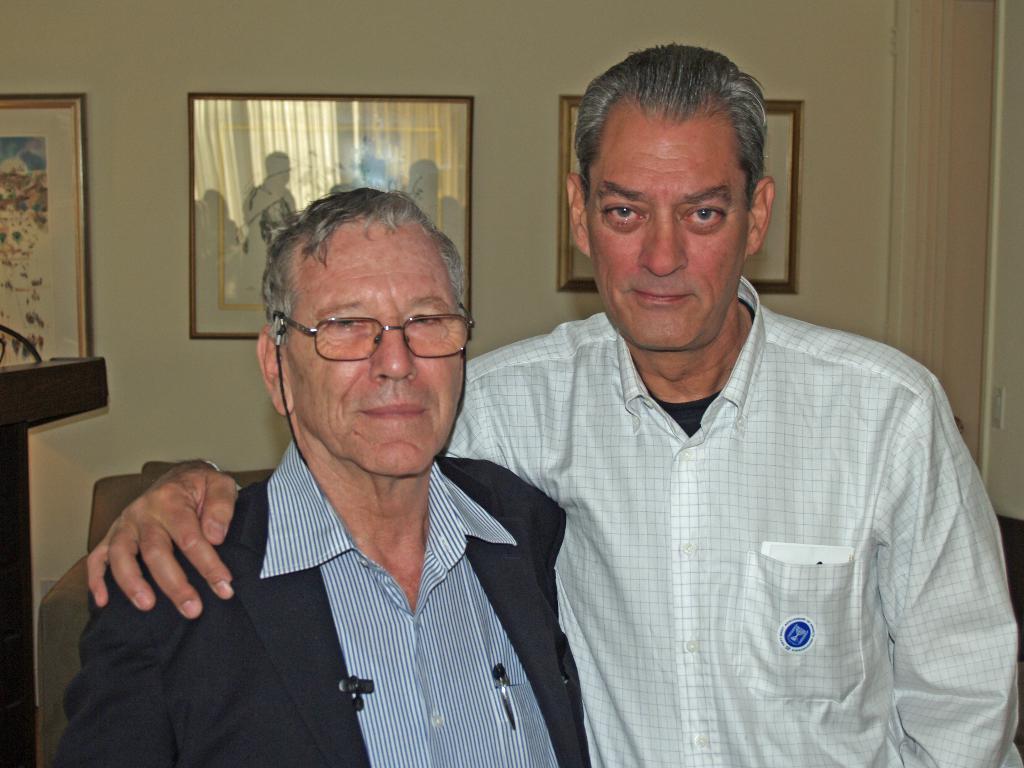Describe this image in one or two sentences. In this image we can see two people standing and posing for a photo and behind we can see there is a couch. In the background, we can see the wall with three photo frames. 